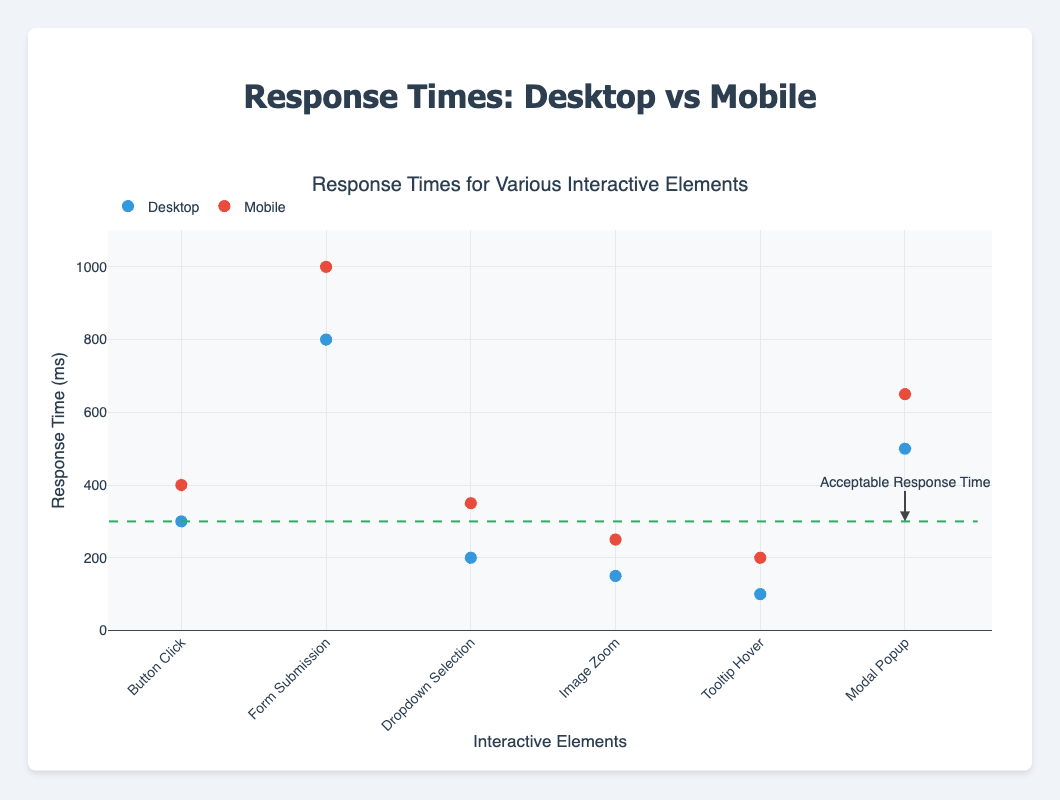What's the title of the plot? The title of the plot is displayed at the top and provides an overview of what the plot represents.
Answer: Response Times for Various Interactive Elements What are the devices being compared in the plot? The legend at the top of the plot indicates the devices being compared, which are "Desktop" and "Mobile".
Answer: Desktop and Mobile Which interactive element has the highest response time for mobile users? The tallest red marker (representing Mobile) indicates the highest response time for mobile users. It is on the "Form Submission" element.
Answer: Form Submission What is the response time for "Image Zoom" on desktop users? The blue marker representing Desktop for the "Image Zoom" element shows the response time as 150 milliseconds.
Answer: 150 milliseconds Which device generally has higher response times across all interactive elements? By comparing the heights of red markers (Mobile) with blue markers (Desktop) across all elements, Mobile generally has higher response times.
Answer: Mobile What’s the difference in response times between mobile and desktop for "Dropdown Selection"? The response time for "Dropdown Selection" on Desktop is 200 ms and for Mobile is 350 ms. The difference is 350 - 200 = 150 ms.
Answer: 150 milliseconds How many interactive elements have response times lower than the acceptable response time (300 ms) for desktop users? By checking the blue markers, the interactive elements with response times under 300 ms are "Dropdown Selection", "Image Zoom", and "Tooltip Hover".
Answer: 3 elements Identify any interactive elements where the Mobile response time is less than 300 milliseconds. The red markers below 300 ms should be checked. The interactive element below 300 ms for Mobile users is "Tooltip Hover".
Answer: Tooltip Hover Which interactive element shows the least difference in response times between desktop and mobile users? The difference in response times is smallest where the Desktop and Mobile markers are closest. For "Modal Popup", the response times are 500 ms (Desktop) and 650 ms (Mobile), a difference of 150 ms.
Answer: Modal Popup What is the average response time for "Form Submission" across both devices? The response times are 800 ms (Desktop) and 1000 ms (Mobile). The average is (800 + 1000) / 2 = 900 ms.
Answer: 900 milliseconds 